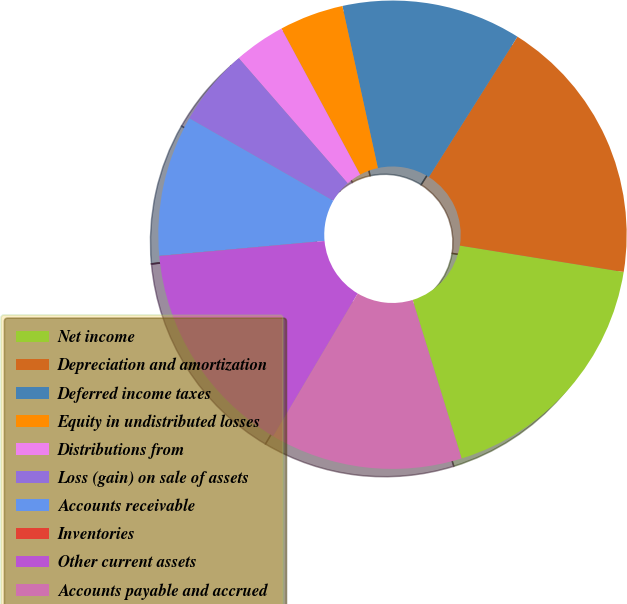Convert chart to OTSL. <chart><loc_0><loc_0><loc_500><loc_500><pie_chart><fcel>Net income<fcel>Depreciation and amortization<fcel>Deferred income taxes<fcel>Equity in undistributed losses<fcel>Distributions from<fcel>Loss (gain) on sale of assets<fcel>Accounts receivable<fcel>Inventories<fcel>Other current assets<fcel>Accounts payable and accrued<nl><fcel>17.69%<fcel>18.58%<fcel>12.39%<fcel>4.43%<fcel>3.54%<fcel>5.31%<fcel>9.73%<fcel>0.01%<fcel>15.04%<fcel>13.27%<nl></chart> 